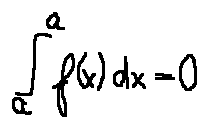<formula> <loc_0><loc_0><loc_500><loc_500>\int \lim i t s _ { a } ^ { a } f ( x ) d x = 0</formula> 